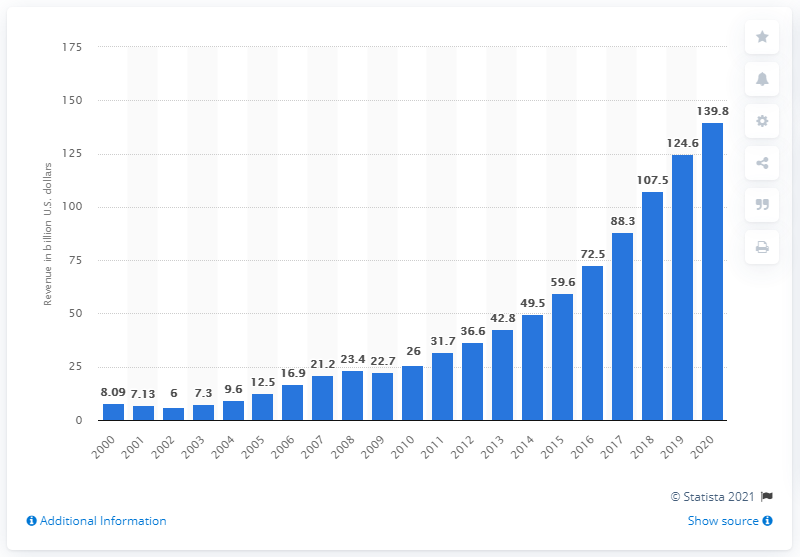Mention a couple of crucial points in this snapshot. In 2020, online advertising revenue in the U.S. was approximately $139.8 billion. 